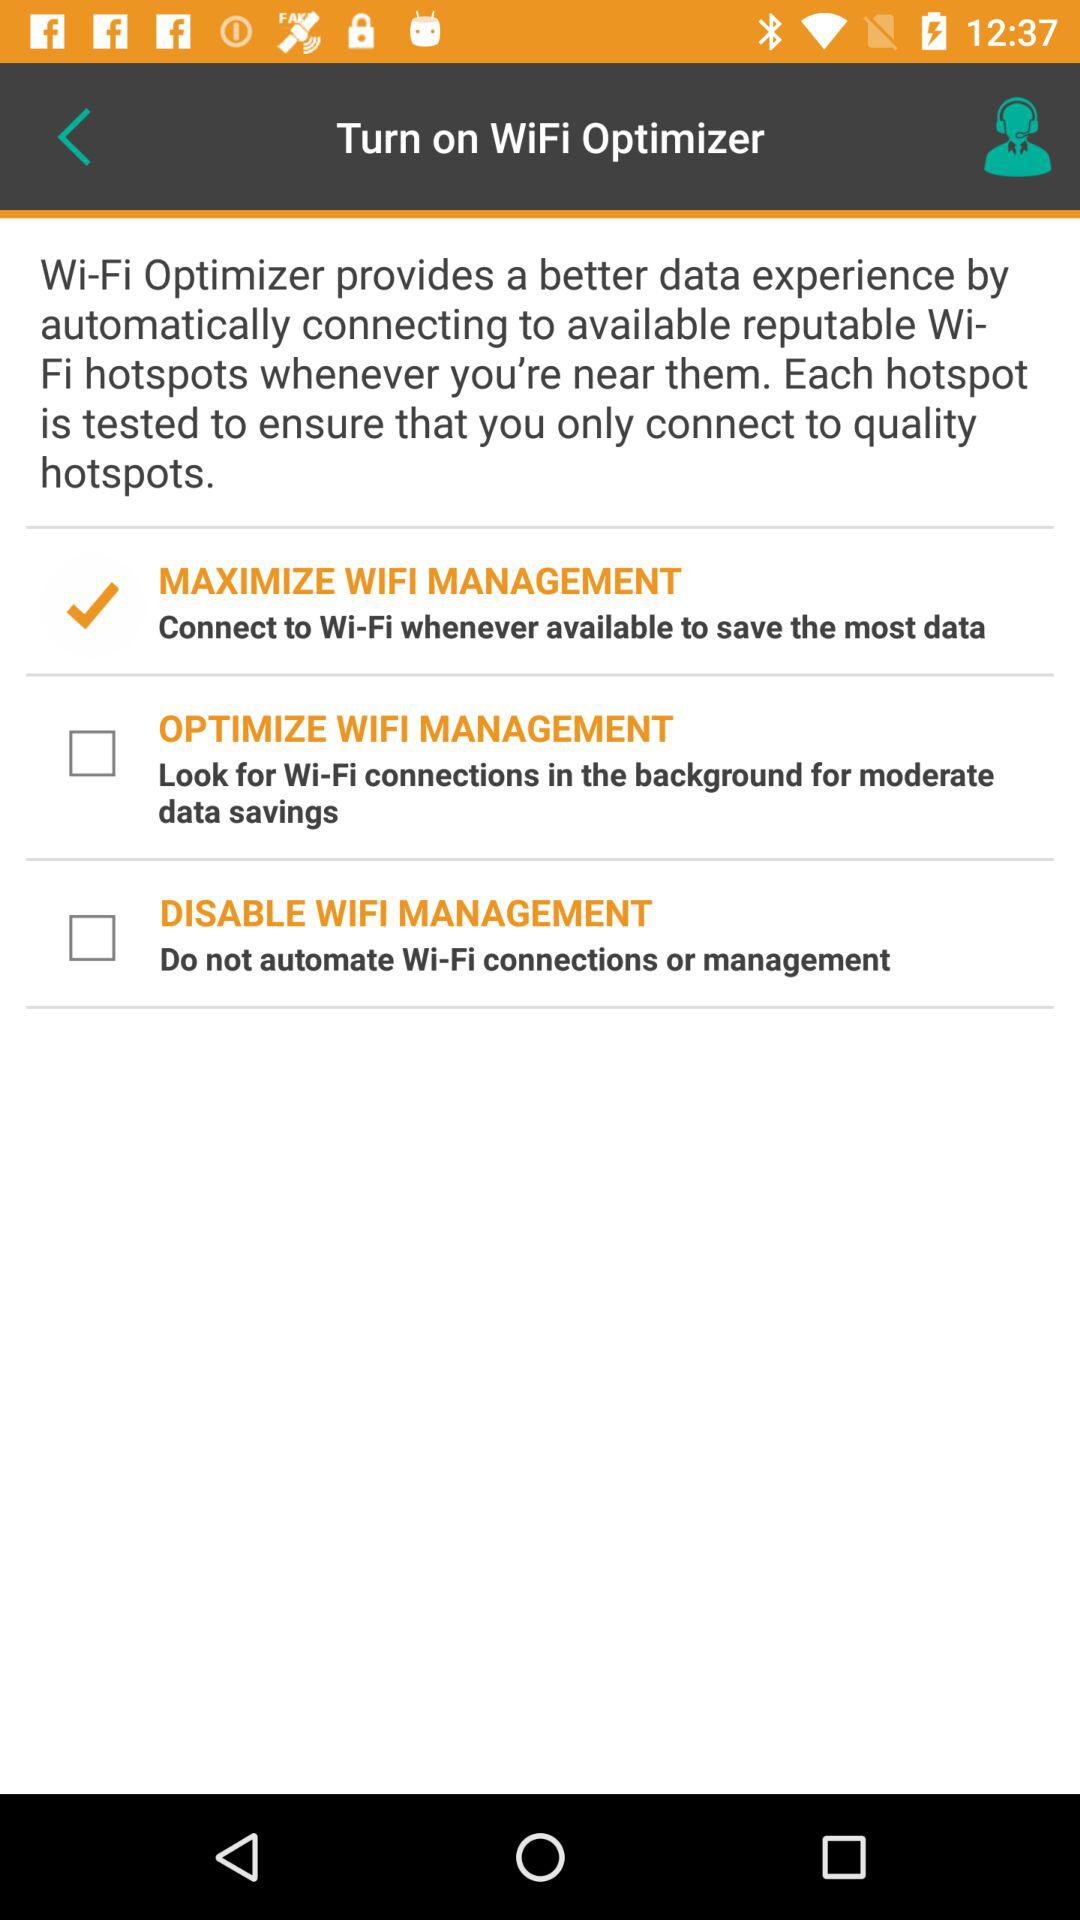How many WiFi management options are there?
Answer the question using a single word or phrase. 3 